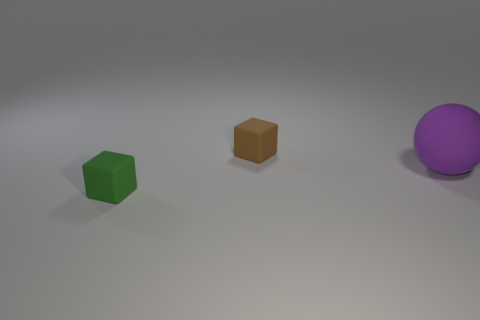Add 3 matte balls. How many objects exist? 6 Subtract all blocks. How many objects are left? 1 Subtract all tiny brown things. Subtract all brown rubber things. How many objects are left? 1 Add 1 purple balls. How many purple balls are left? 2 Add 3 cyan metallic blocks. How many cyan metallic blocks exist? 3 Subtract 0 gray blocks. How many objects are left? 3 